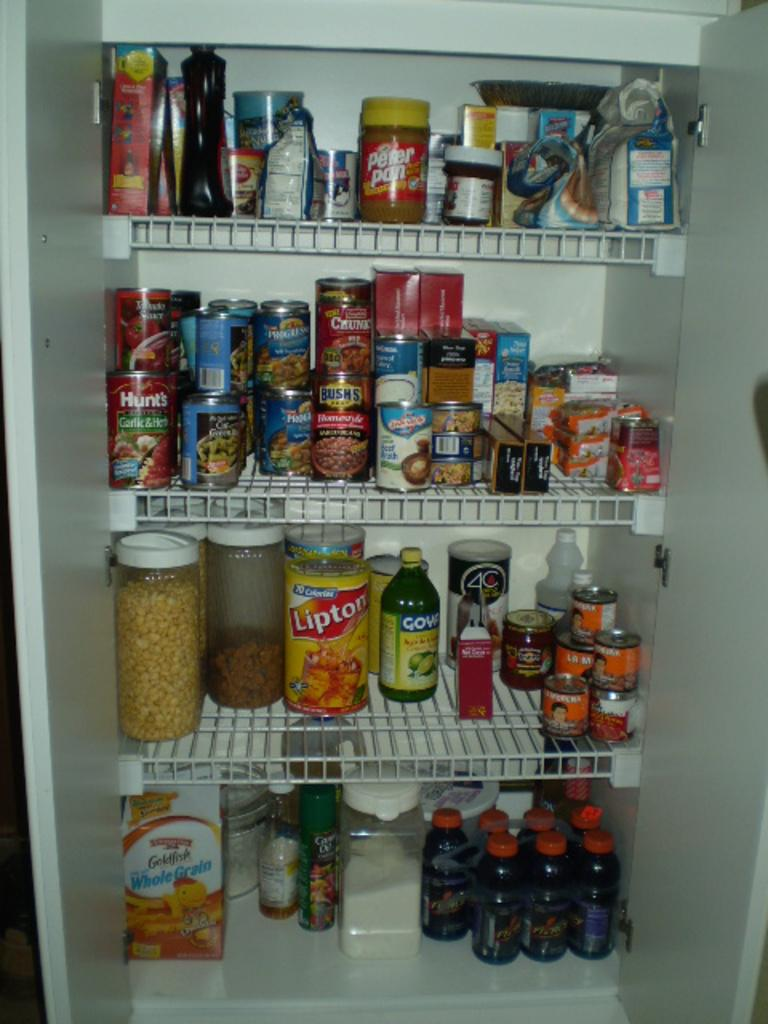Provide a one-sentence caption for the provided image. A pantry with four shelves is full of food, including Lipton Iced Tea, baked beans, peanut butter and many other items. 